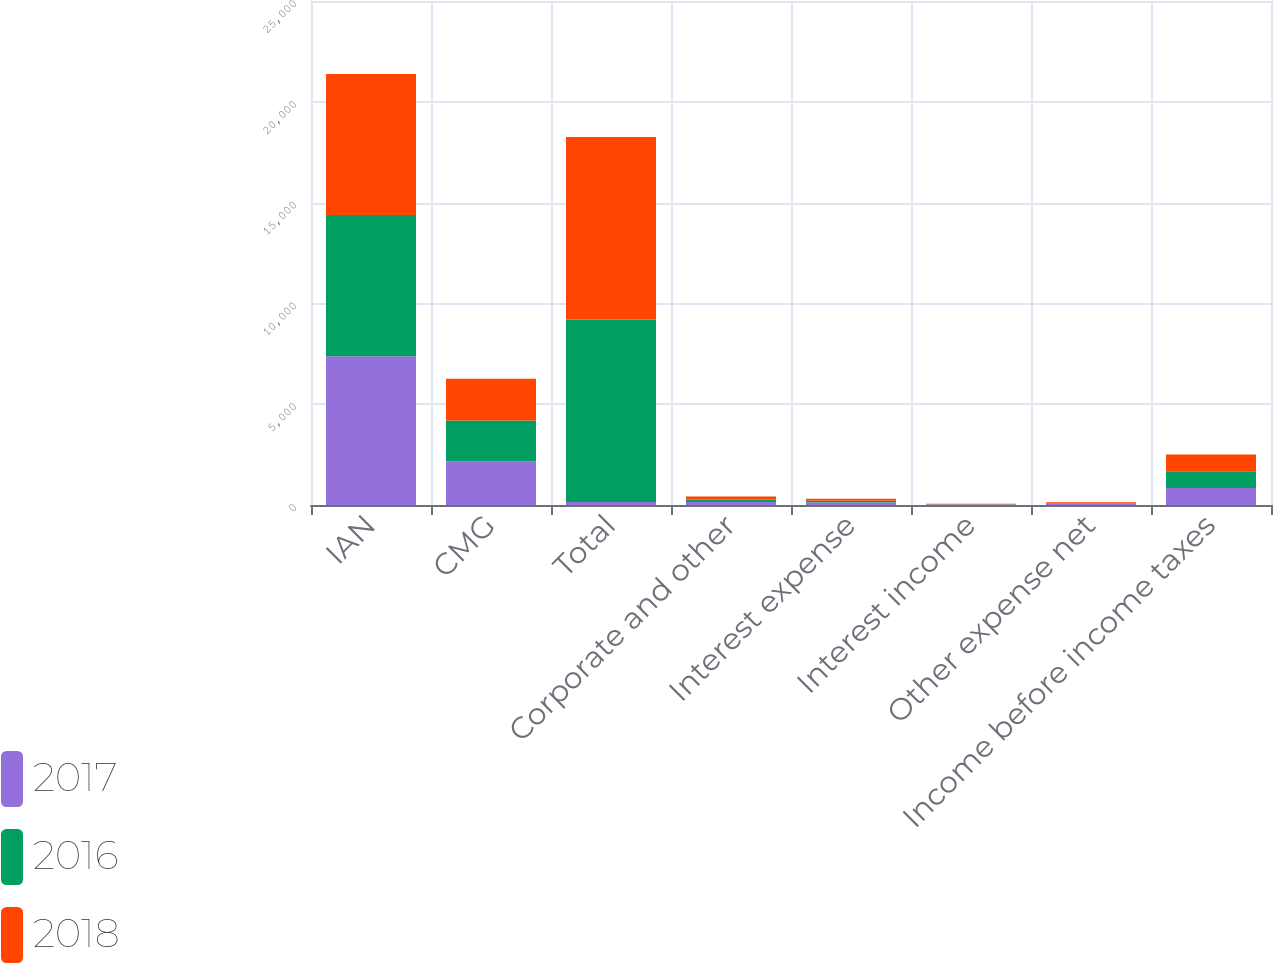Convert chart to OTSL. <chart><loc_0><loc_0><loc_500><loc_500><stacked_bar_chart><ecel><fcel>IAN<fcel>CMG<fcel>Total<fcel>Corporate and other<fcel>Interest expense<fcel>Interest income<fcel>Other expense net<fcel>Income before income taxes<nl><fcel>2017<fcel>7374.4<fcel>2158.3<fcel>149<fcel>149<fcel>123<fcel>21.8<fcel>69.6<fcel>838<nl><fcel>2016<fcel>7009.6<fcel>2038<fcel>9047.6<fcel>126.6<fcel>90.8<fcel>19.4<fcel>26.2<fcel>840.8<nl><fcel>2018<fcel>6992.8<fcel>2063.4<fcel>9056.2<fcel>147.2<fcel>90.6<fcel>20.1<fcel>40.3<fcel>825.6<nl></chart> 